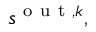Convert formula to latex. <formula><loc_0><loc_0><loc_500><loc_500>s ^ { o u t , k } ,</formula> 